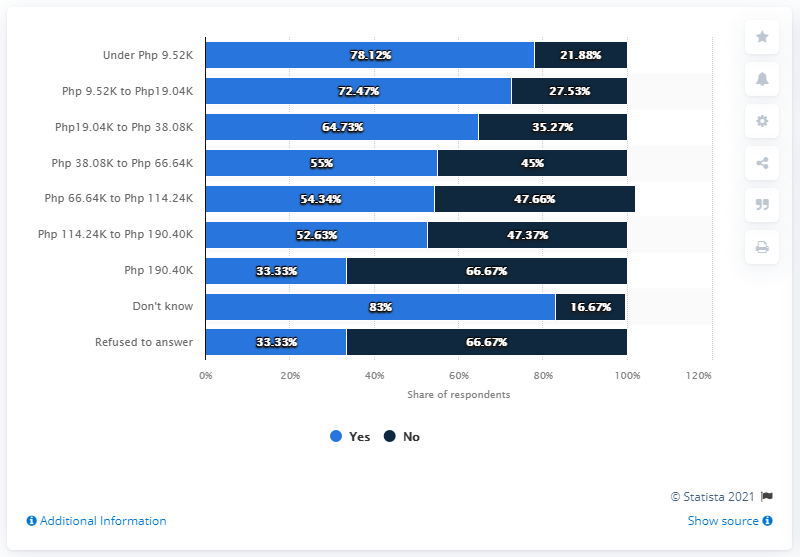Indicate a few pertinent items in this graphic. During the Economic Census of Establishments (ECQ) in the Philippines, approximately 66.67% of households with a member earning below 9,500 Philippine pesos did not experience job loss. 